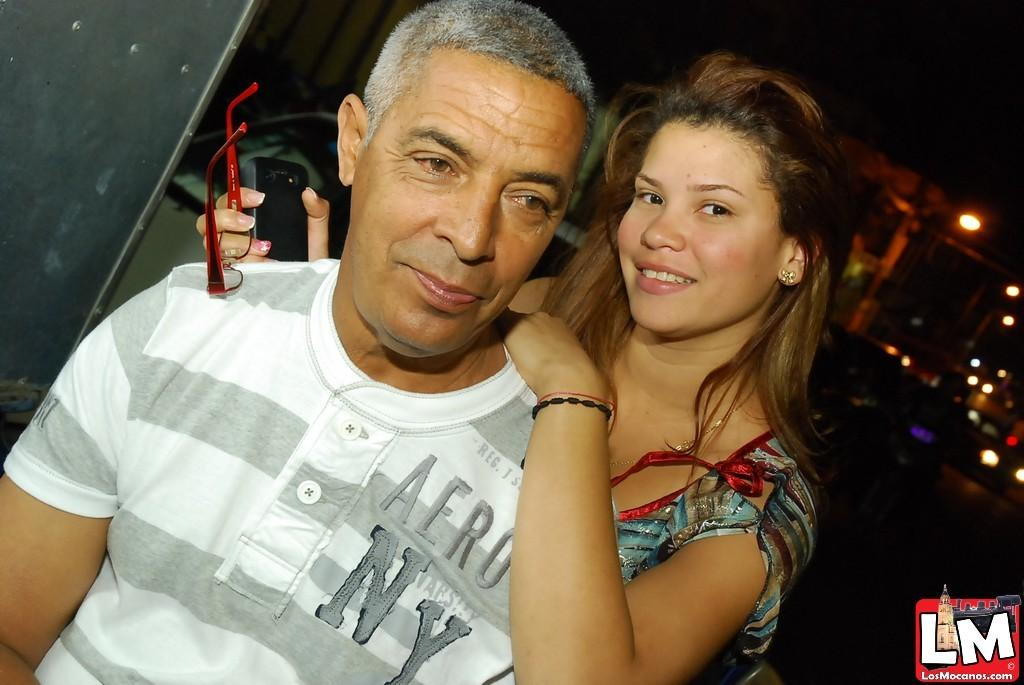Who is the main subject in the image? There is a girl in the image. What is the girl's position in relation to another person in the image? The girl is standing behind an old man. What is the old man wearing? The old man is wearing a white t-shirt. What can be seen in the background of the image? There are lights visible in the background of the image. What type of plastic is used to make the wine glasses in the image? There are no wine glasses present in the image, so it is not possible to determine the type of plastic used. 